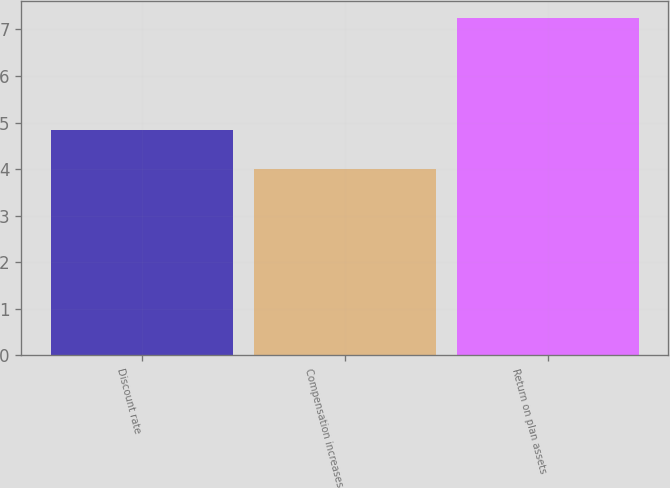Convert chart to OTSL. <chart><loc_0><loc_0><loc_500><loc_500><bar_chart><fcel>Discount rate<fcel>Compensation increases<fcel>Return on plan assets<nl><fcel>4.85<fcel>4<fcel>7.25<nl></chart> 